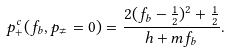<formula> <loc_0><loc_0><loc_500><loc_500>p _ { + } ^ { c } ( f _ { b } , p _ { \neq } = 0 ) = \frac { 2 ( f _ { b } - \frac { 1 } { 2 } ) ^ { 2 } + \frac { 1 } { 2 } } { h + m f _ { b } } .</formula> 